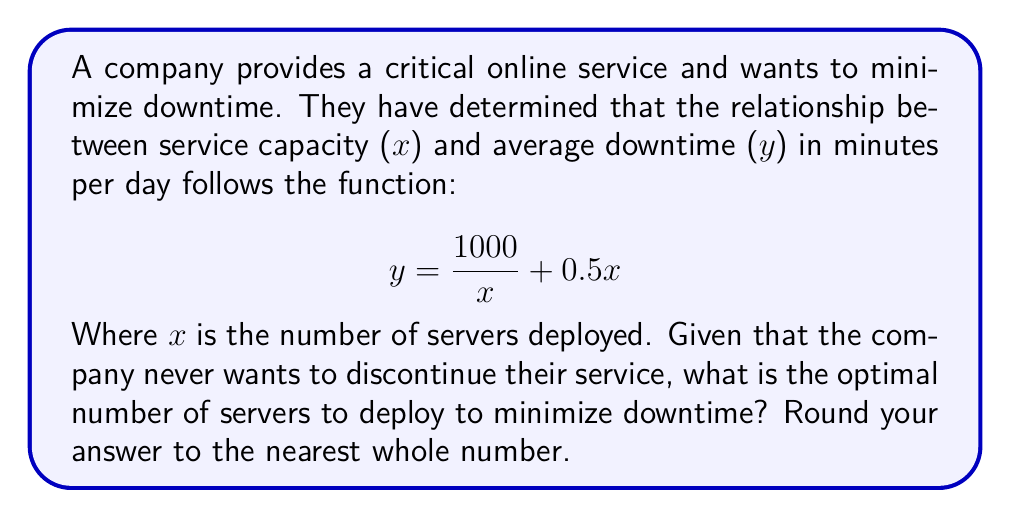Help me with this question. To find the optimal number of servers that minimizes downtime, we need to find the minimum point of the function. This can be done by following these steps:

1) First, we need to find the derivative of the function:
   $$ y = \frac{1000}{x} + 0.5x $$
   $$ \frac{dy}{dx} = -\frac{1000}{x^2} + 0.5 $$

2) To find the minimum point, we set the derivative equal to zero and solve for x:
   $$ -\frac{1000}{x^2} + 0.5 = 0 $$
   $$ \frac{1000}{x^2} = 0.5 $$
   $$ 1000 = 0.5x^2 $$
   $$ 2000 = x^2 $$
   $$ x = \sqrt{2000} \approx 44.72 $$

3) To confirm this is a minimum (not a maximum), we can check the second derivative:
   $$ \frac{d^2y}{dx^2} = \frac{2000}{x^3} $$
   This is always positive for positive x, confirming we have found a minimum.

4) Since we can't deploy a fractional number of servers, we need to round to the nearest whole number.

5) Given the persona of "a user who never trusts discontinuing services", we should round up to ensure we have slightly more capacity than the mathematical optimum. This aligns with the goal of minimizing downtime and never discontinuing service.
Answer: The optimal number of servers to deploy is 45. 